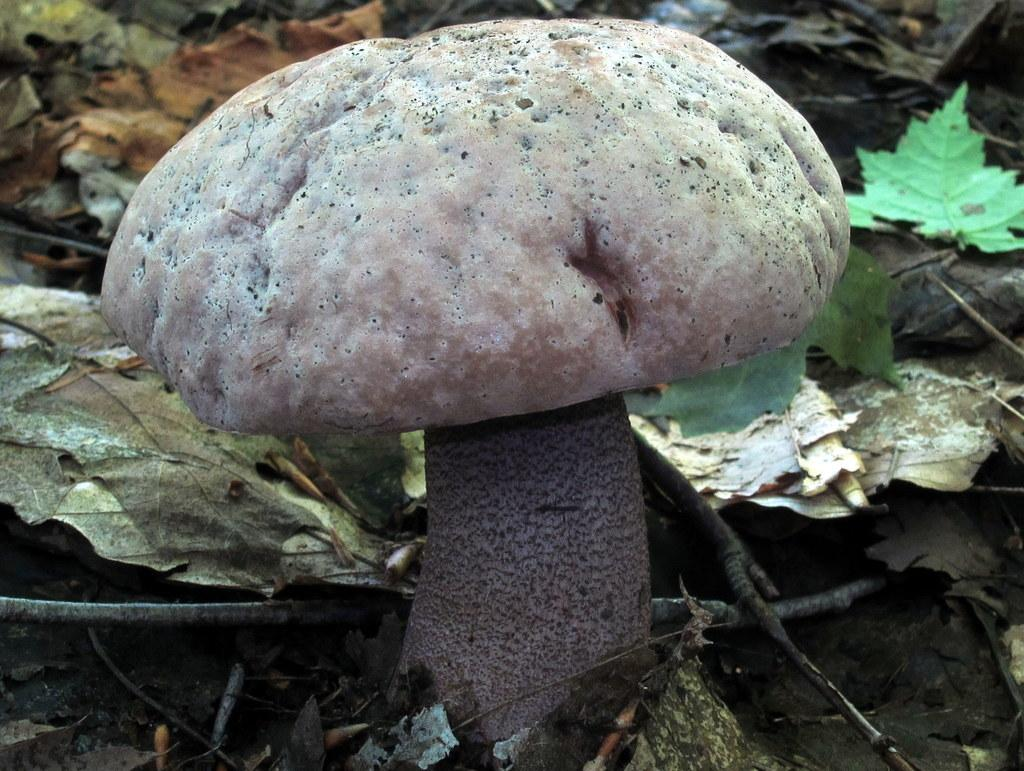What is the main subject in the center of the image? There is a mushroom in the center of the image. What can be seen in the background of the image? There are leaves and twigs in the background of the image. How many pizzas are stacked on top of the mushroom in the image? There are no pizzas present in the image; it features a mushroom and background elements. What type of hat is the mushroom wearing in the image? The mushroom is not wearing a hat in the image; it is a natural object. 